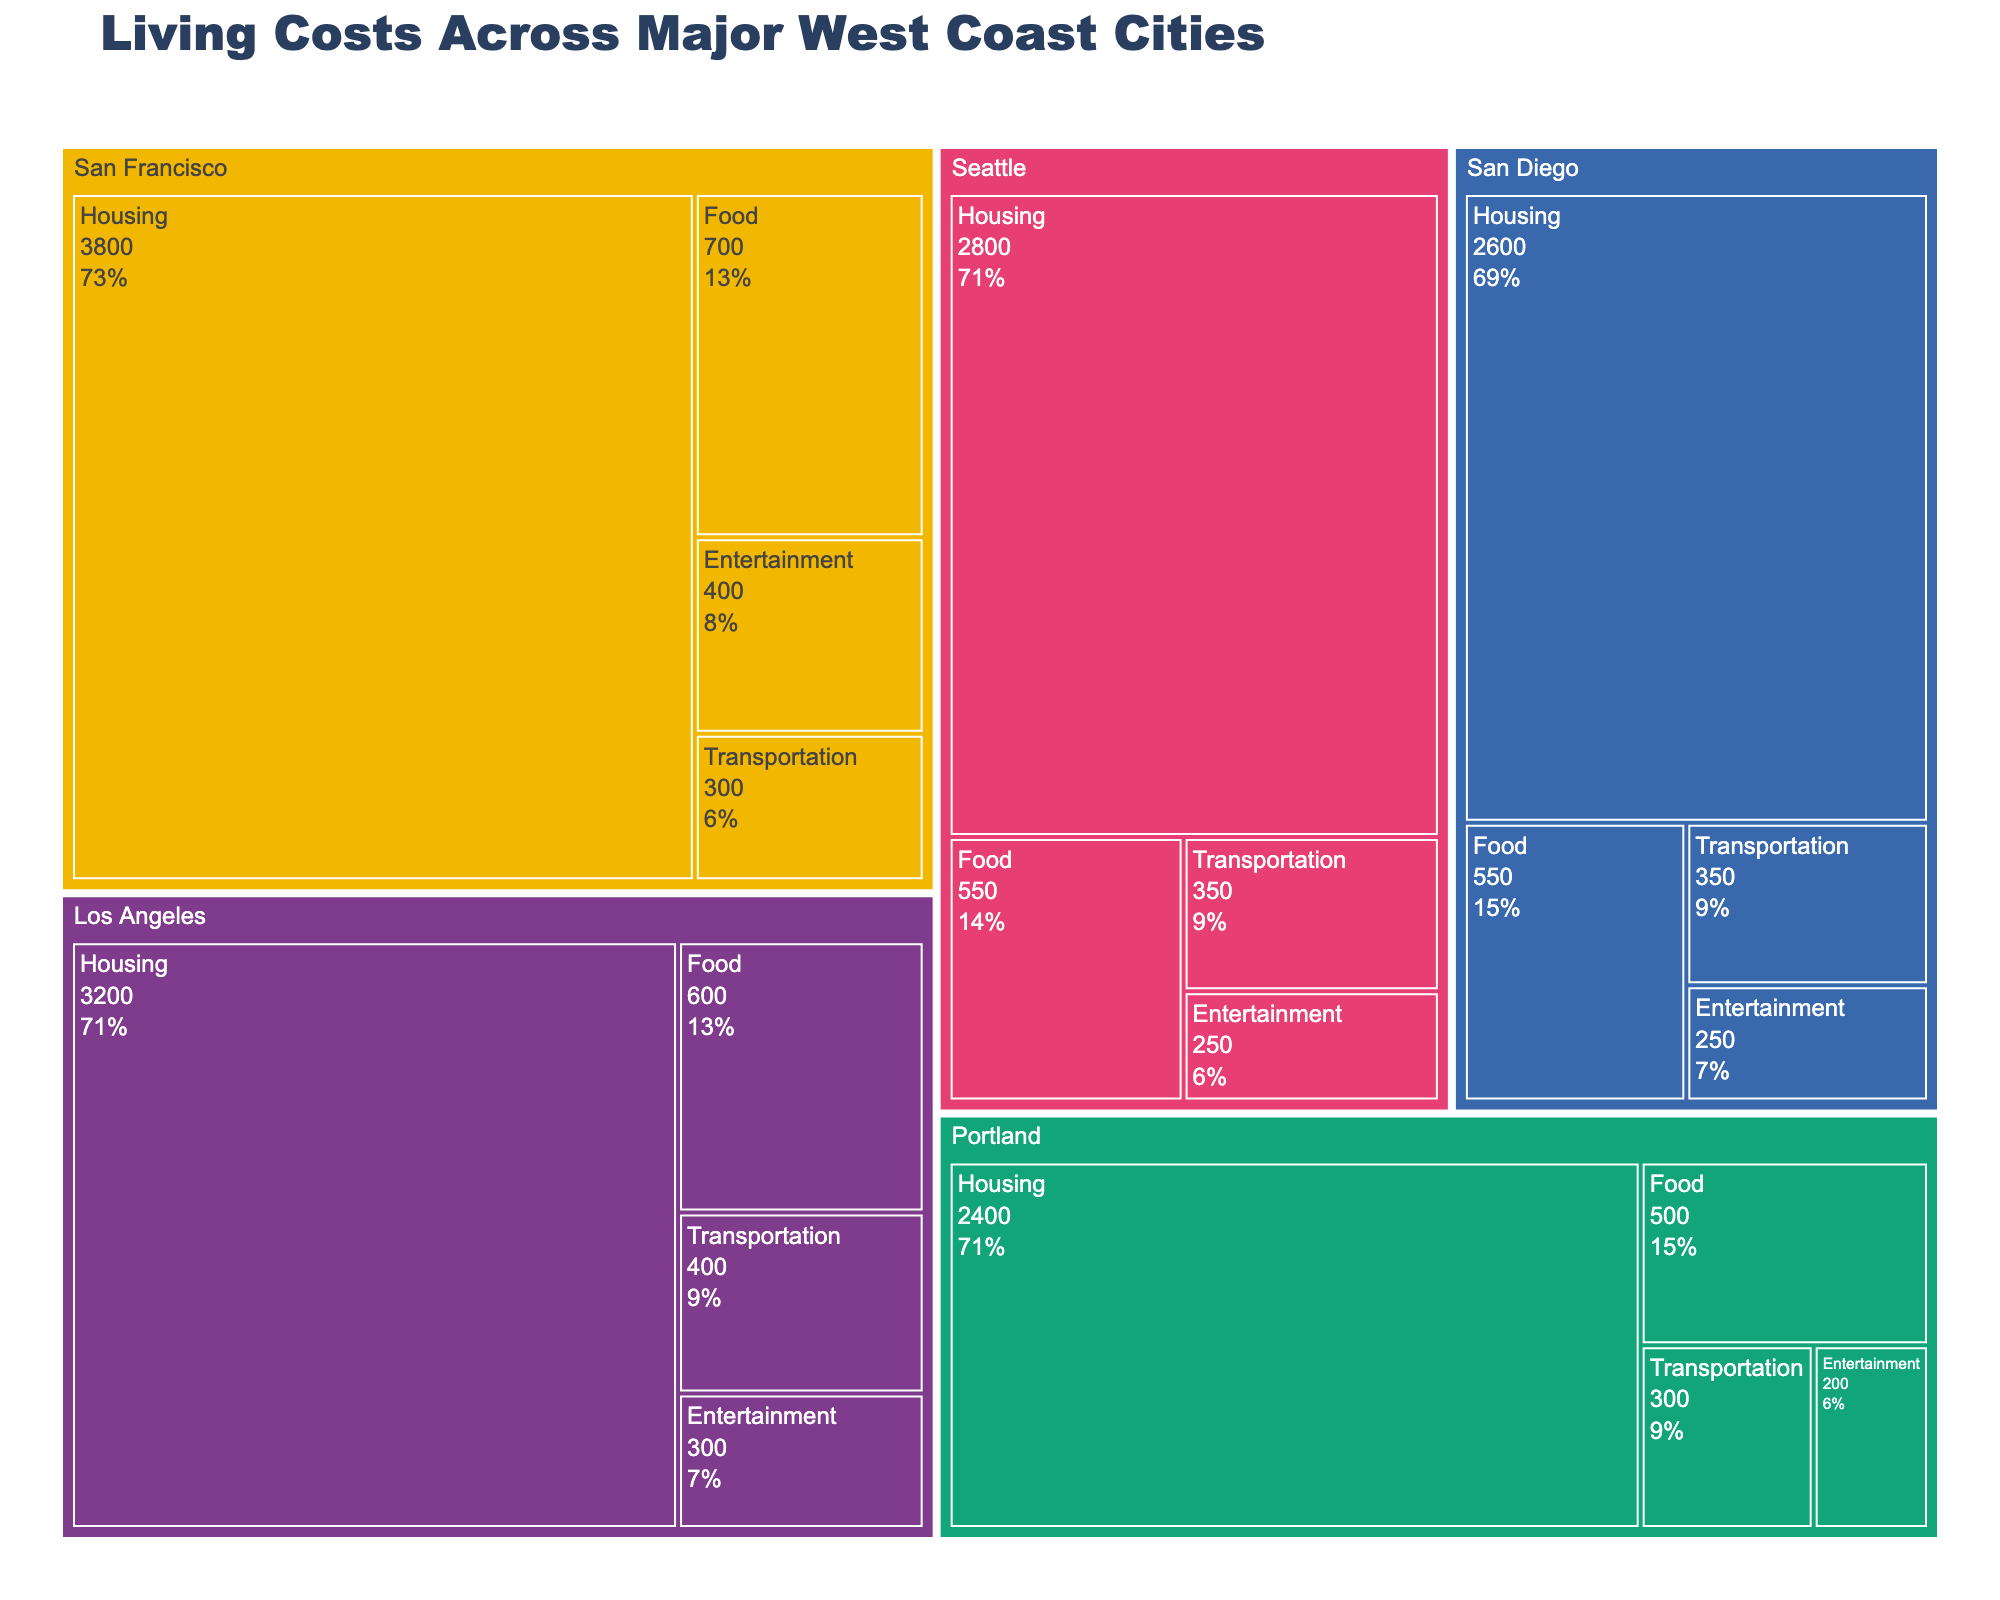What's the title of the figure? The title is usually located at the top of the figure, and in this case, it reads "Living Costs Across Major West Coast Cities."
Answer: Living Costs Across Major West Coast Cities What city has the highest cost for housing? Looking at the treemap, the largest section under the "Housing" category is represented by San Francisco.
Answer: San Francisco Which category has the highest cost in each city? In a treemap, the size of the sections can indicate which category has the highest cost. For all cities, the "Housing" category has the largest section, indicating it has the highest cost.
Answer: Housing What is the total cost for transportation in all cities combined? Look at the “Transportation” category for each city and sum the values: Los Angeles (400), San Francisco (300), Seattle (350), Portland (300), San Diego (350). Sum them up: 400 + 300 + 350 + 300 + 350 = 1700.
Answer: 1700 How does Los Angeles' entertainment cost compare to Seattle's? Find the "Entertainment" category for both Los Angeles and Seattle. Los Angeles has a cost of 300, while Seattle has a cost of 250. Compare these two values.
Answer: Los Angeles has a higher entertainment cost than Seattle Which city has the lowest total cost across all categories? Summing the costs of each category for each city: 
Los Angeles: 3200 + 600 + 400 + 300 = 4500 
San Francisco: 3800 + 700 + 300 + 400 = 5200 
Seattle: 2800 + 550 + 350 + 250 = 3950 
Portland: 2400 + 500 + 300 + 200 = 3400 
San Diego: 2600 + 550 + 350 + 250 = 3750 
Portland has the lowest total cost.
Answer: Portland What percentage of San Francisco's total cost is attributed to food? First, calculate the total cost for San Francisco: 3800 + 700 + 300 + 400 = 5200. Then calculate the percentage of food cost: (700 / 5200) * 100 = 13.46%.
Answer: 13.46% How does the housing cost in Seattle compare to the food cost in San Francisco? Look at the housing cost for Seattle (2800) and the food cost for San Francisco (700). Compare these two values.
Answer: Seattle's housing cost is higher than San Francisco's food cost What's the average cost of entertainment across all cities? Sum the entertainment costs for all cities: 300 (LA) + 400 (SF) + 250 (Seattle) + 200 (Portland) + 250 (San Diego) = 1400. Divide by 5 cities: 1400 / 5 = 280.
Answer: 280 What city and category combination represents a cost of $400? Look for the sections labeled with $400 in the treemap. The combinations are San Francisco for entertainment and Los Angeles for transportation.
Answer: San Francisco Entertainment and Los Angeles Transportation 